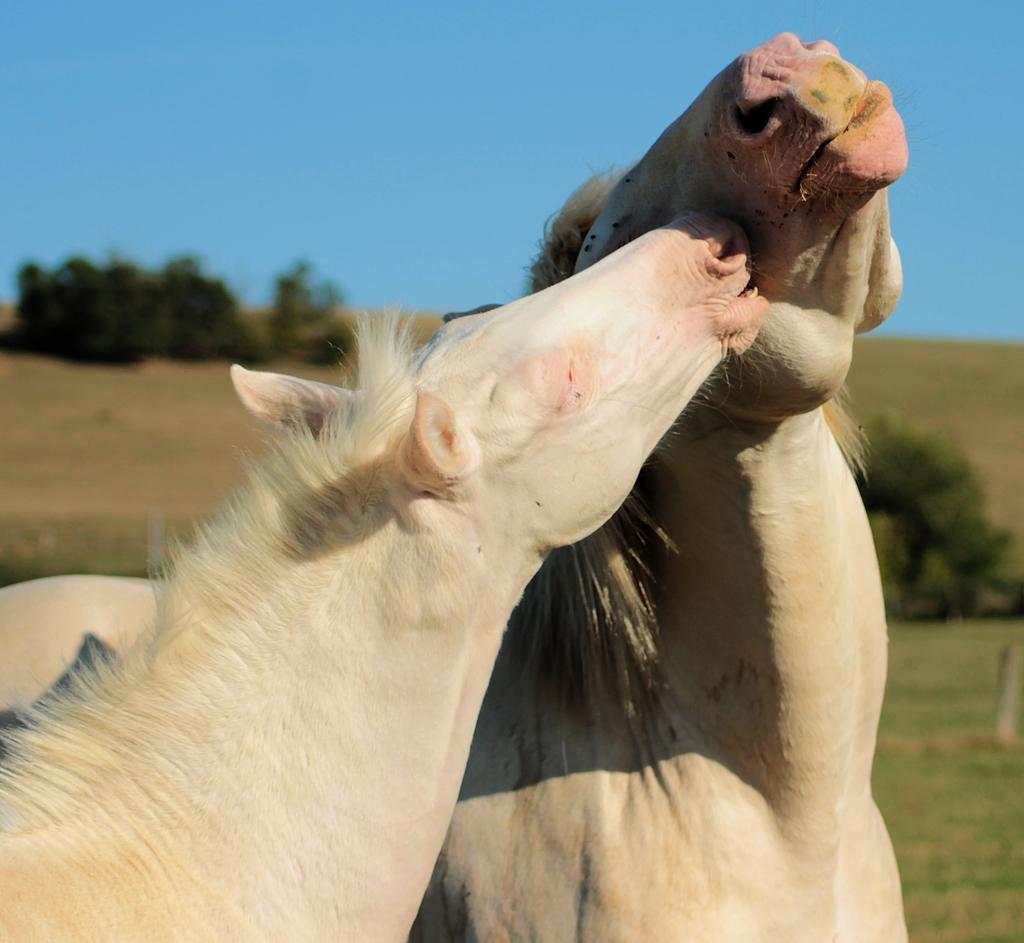How many horses are present in the image? There are two horses in the image. What color are the horses? The horses are white in color. What can be seen in the background of the image? There are trees and the clear sky visible in the background of the image. Is there an argument taking place between the horses in the image? There is no indication of an argument or any interaction between the horses in the image. 